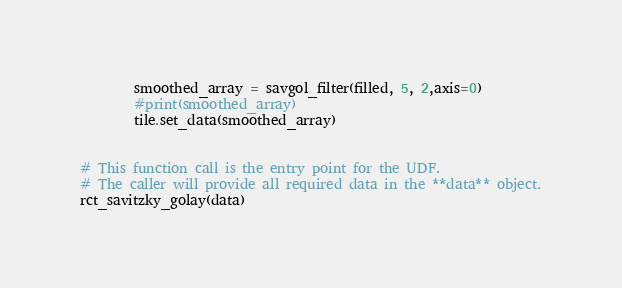Convert code to text. <code><loc_0><loc_0><loc_500><loc_500><_Python_>        smoothed_array = savgol_filter(filled, 5, 2,axis=0)
        #print(smoothed_array)
        tile.set_data(smoothed_array)


# This function call is the entry point for the UDF.
# The caller will provide all required data in the **data** object.
rct_savitzky_golay(data)
</code> 